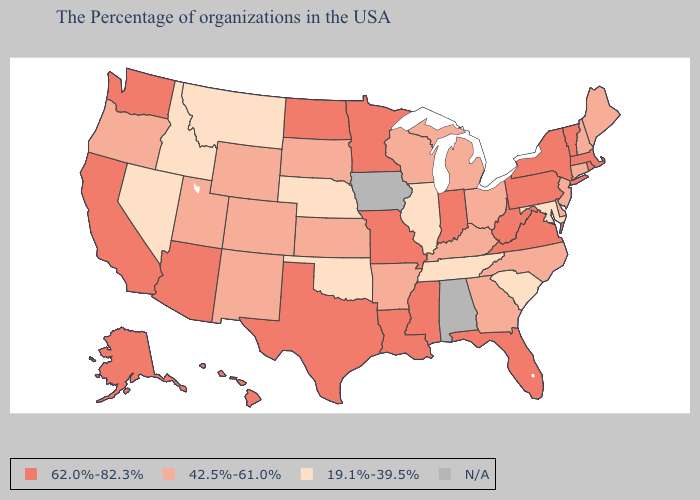Which states have the highest value in the USA?
Keep it brief. Massachusetts, Rhode Island, Vermont, New York, Pennsylvania, Virginia, West Virginia, Florida, Indiana, Mississippi, Louisiana, Missouri, Minnesota, Texas, North Dakota, Arizona, California, Washington, Alaska, Hawaii. Among the states that border Tennessee , does Missouri have the lowest value?
Keep it brief. No. What is the value of Louisiana?
Concise answer only. 62.0%-82.3%. Does Arizona have the highest value in the West?
Write a very short answer. Yes. Among the states that border Arkansas , does Louisiana have the lowest value?
Write a very short answer. No. What is the highest value in the USA?
Quick response, please. 62.0%-82.3%. Does Nebraska have the lowest value in the USA?
Give a very brief answer. Yes. What is the highest value in states that border Nevada?
Concise answer only. 62.0%-82.3%. Among the states that border New Hampshire , does Maine have the highest value?
Quick response, please. No. What is the value of Missouri?
Give a very brief answer. 62.0%-82.3%. What is the value of Alabama?
Be succinct. N/A. What is the value of Colorado?
Write a very short answer. 42.5%-61.0%. Name the states that have a value in the range N/A?
Quick response, please. Alabama, Iowa. Name the states that have a value in the range 19.1%-39.5%?
Keep it brief. Maryland, South Carolina, Tennessee, Illinois, Nebraska, Oklahoma, Montana, Idaho, Nevada. 